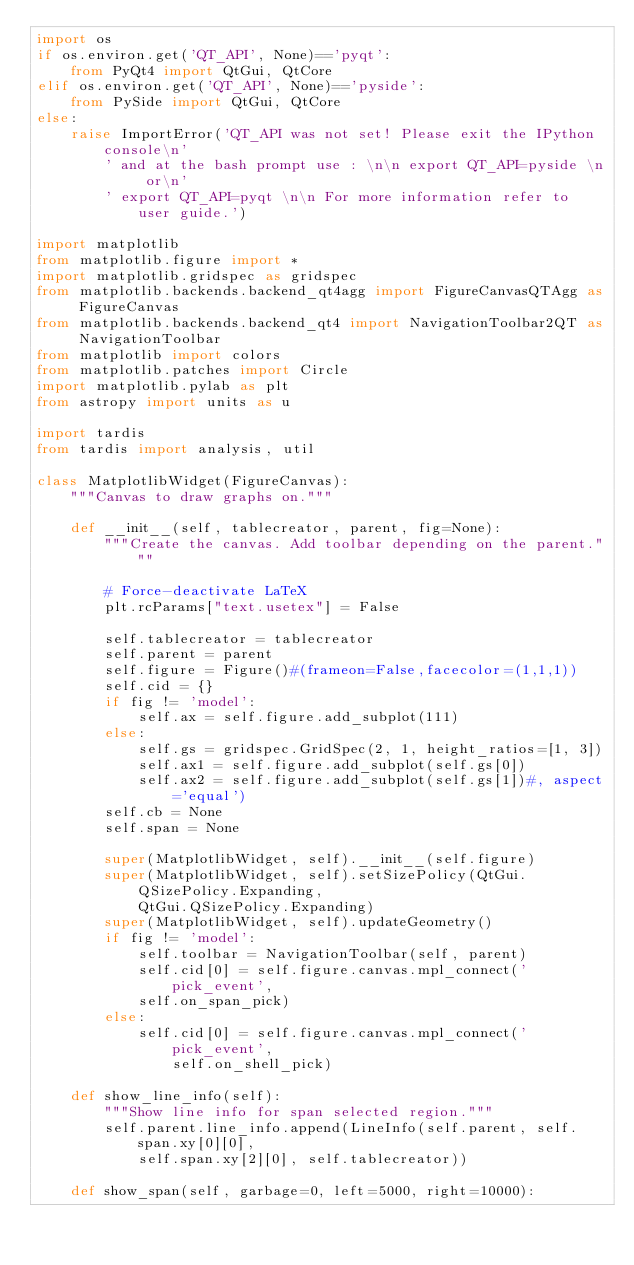<code> <loc_0><loc_0><loc_500><loc_500><_Python_>import os
if os.environ.get('QT_API', None)=='pyqt':
    from PyQt4 import QtGui, QtCore
elif os.environ.get('QT_API', None)=='pyside':
    from PySide import QtGui, QtCore
else:
    raise ImportError('QT_API was not set! Please exit the IPython console\n'
        ' and at the bash prompt use : \n\n export QT_API=pyside \n or\n'
        ' export QT_API=pyqt \n\n For more information refer to user guide.')

import matplotlib
from matplotlib.figure import *
import matplotlib.gridspec as gridspec
from matplotlib.backends.backend_qt4agg import FigureCanvasQTAgg as FigureCanvas
from matplotlib.backends.backend_qt4 import NavigationToolbar2QT as NavigationToolbar
from matplotlib import colors
from matplotlib.patches import Circle
import matplotlib.pylab as plt
from astropy import units as u

import tardis
from tardis import analysis, util

class MatplotlibWidget(FigureCanvas):
    """Canvas to draw graphs on."""

    def __init__(self, tablecreator, parent, fig=None):
        """Create the canvas. Add toolbar depending on the parent."""

        # Force-deactivate LaTeX
        plt.rcParams["text.usetex"] = False

        self.tablecreator = tablecreator
        self.parent = parent
        self.figure = Figure()#(frameon=False,facecolor=(1,1,1))
        self.cid = {}
        if fig != 'model':
            self.ax = self.figure.add_subplot(111)
        else:
            self.gs = gridspec.GridSpec(2, 1, height_ratios=[1, 3])
            self.ax1 = self.figure.add_subplot(self.gs[0])
            self.ax2 = self.figure.add_subplot(self.gs[1])#, aspect='equal')
        self.cb = None
        self.span = None

        super(MatplotlibWidget, self).__init__(self.figure)
        super(MatplotlibWidget, self).setSizePolicy(QtGui.QSizePolicy.Expanding,
            QtGui.QSizePolicy.Expanding)
        super(MatplotlibWidget, self).updateGeometry()
        if fig != 'model':
            self.toolbar = NavigationToolbar(self, parent)
            self.cid[0] = self.figure.canvas.mpl_connect('pick_event',
            self.on_span_pick)
        else:
            self.cid[0] = self.figure.canvas.mpl_connect('pick_event',
                self.on_shell_pick)

    def show_line_info(self):
        """Show line info for span selected region."""
        self.parent.line_info.append(LineInfo(self.parent, self.span.xy[0][0],
            self.span.xy[2][0], self.tablecreator))

    def show_span(self, garbage=0, left=5000, right=10000):</code> 